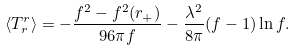Convert formula to latex. <formula><loc_0><loc_0><loc_500><loc_500>\langle T _ { r } ^ { r } \rangle = - { \frac { f ^ { 2 } - f ^ { 2 } ( r _ { + } ) } { 9 6 \pi f } } - { \frac { \lambda ^ { 2 } } { 8 \pi } } ( f - 1 ) \ln f .</formula> 